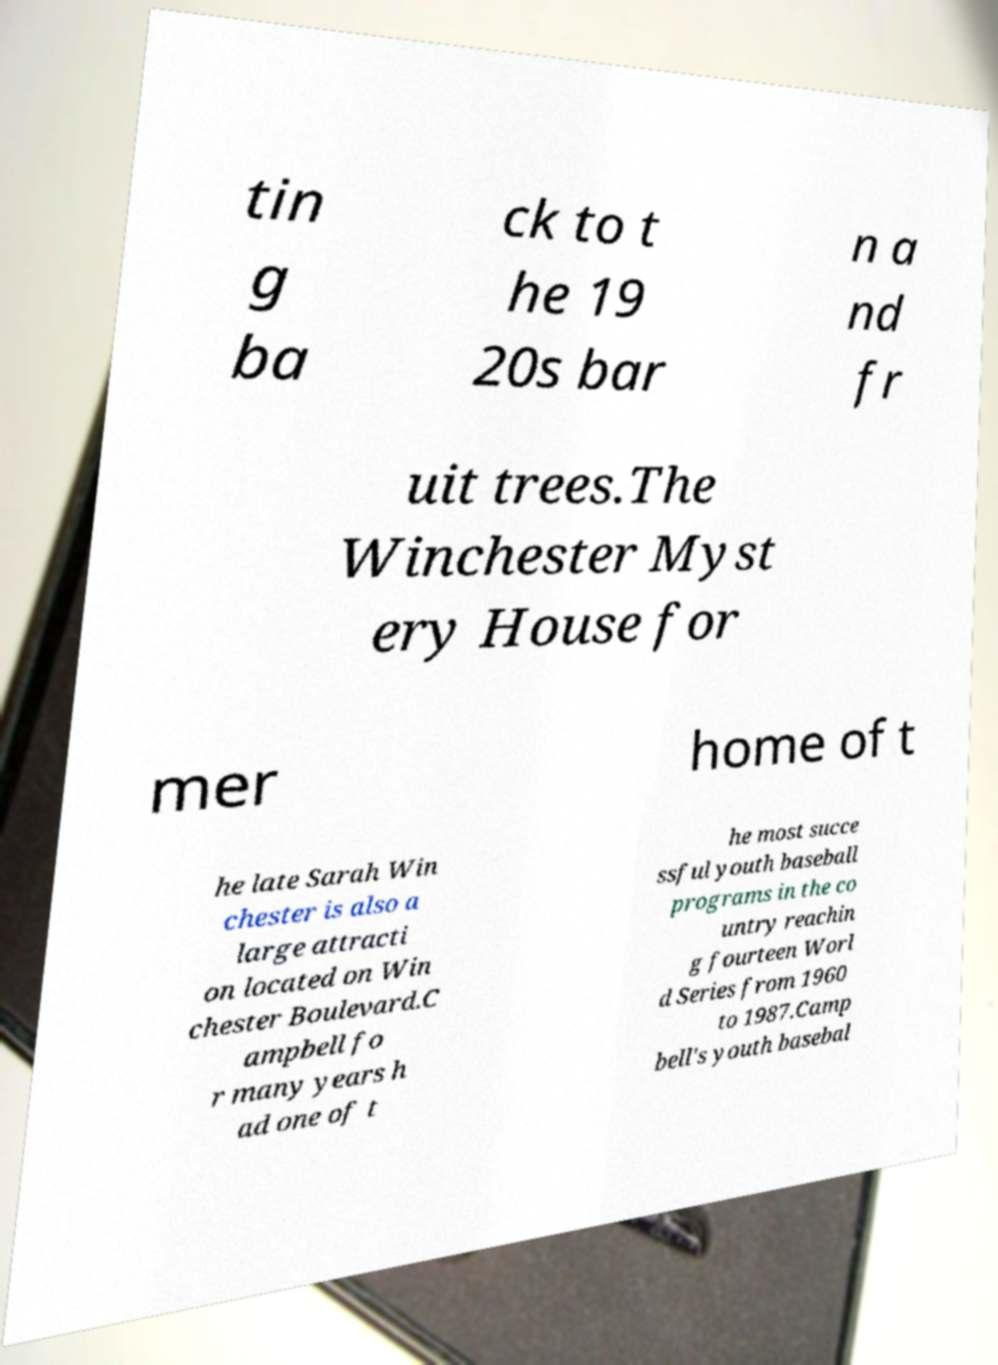For documentation purposes, I need the text within this image transcribed. Could you provide that? tin g ba ck to t he 19 20s bar n a nd fr uit trees.The Winchester Myst ery House for mer home of t he late Sarah Win chester is also a large attracti on located on Win chester Boulevard.C ampbell fo r many years h ad one of t he most succe ssful youth baseball programs in the co untry reachin g fourteen Worl d Series from 1960 to 1987.Camp bell's youth basebal 